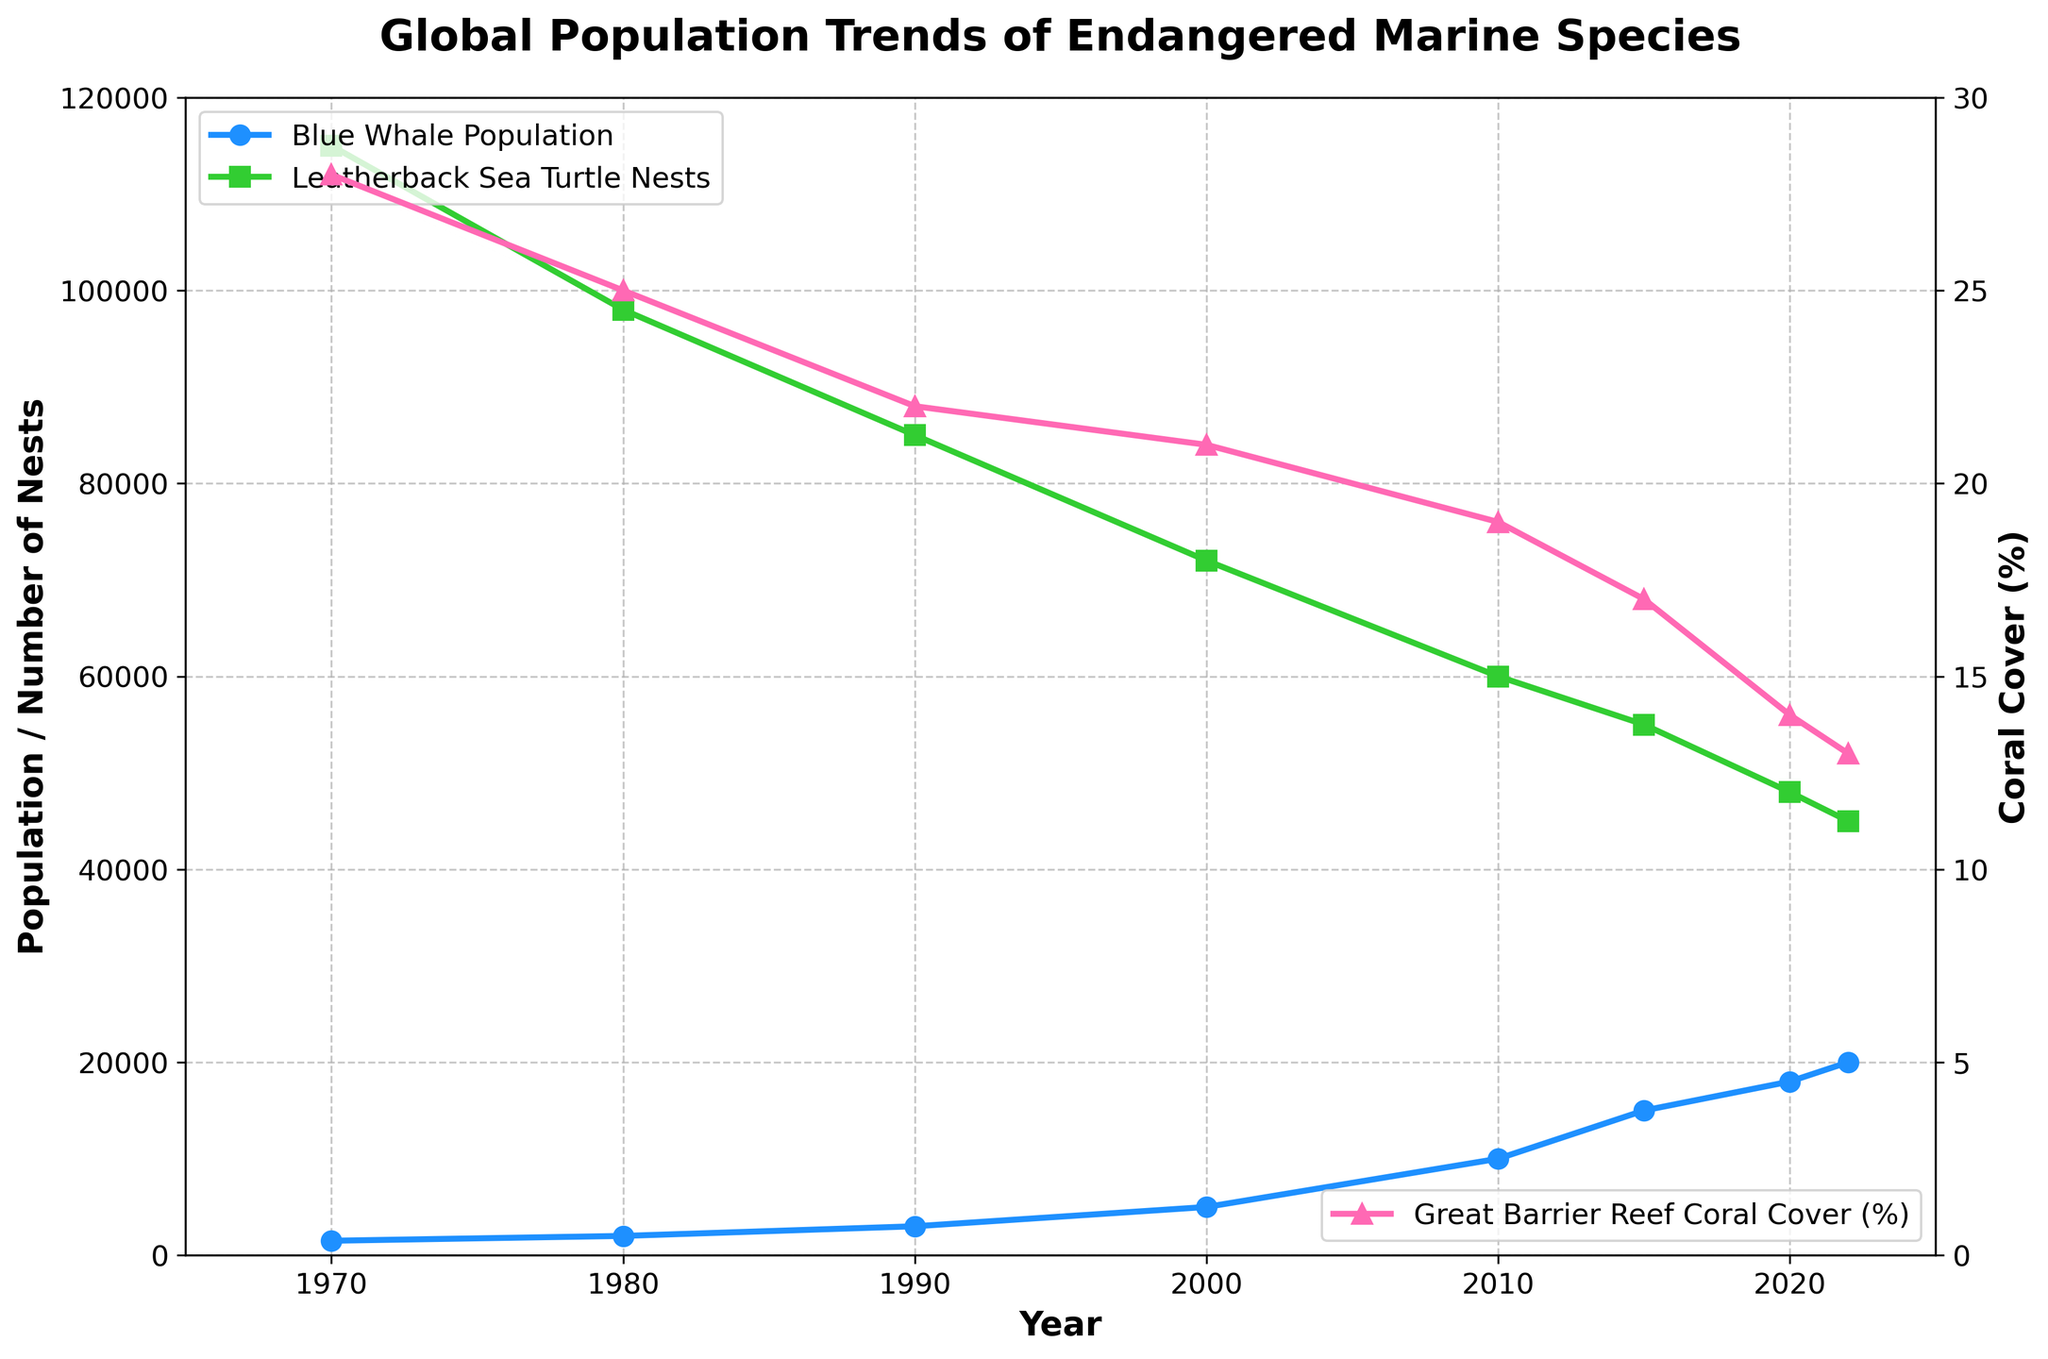What is the trend in the Blue Whale population from 1970 to 2022? The Blue Whale population has increased from 1500 in 1970 to 20000 in 2022. Looking at the line graph, we can see a consistent upward trend over the entire period.
Answer: Blue Whales show an increasing trend What was the population difference of Blue Whales between the years 2000 and 2010? The Blue Whale population in 2000 was 5000, and in 2010 it was 10000. To find the difference, we subtract the 2000 value from the 2010 value: 10000 - 5000 = 5000.
Answer: 5000 How does the Leatherback Sea Turtle nests number in 1990 compare to that in 2020? In 1990, the number of Leatherback Sea Turtle nests was 85000, and in 2020, it was 48000. By comparing these values, we see a significant decrease over this period.
Answer: Decreased What is the average Great Barrier Reef Coral Cover percentage between 1970 and 2015? To find the average, add the percentage values for the years 1970, 1980, 1990, 2000, 2010, and 2015 (28 + 25 + 22 + 21 + 19 + 17) and divide by the number of years (6). So, (28 + 25 + 22 + 21 + 19 + 17) / 6 = 132 / 6 = 22.
Answer: 22 Which species had the steepest decline in the observed period? Looking at the slopes of the lines, the Great Barrier Reef Coral Cover showed the steepest decline from 28% in 1970 to 13% in 2022. Visually, the pink-colored line representing coral cover descends more sharply than the other lines.
Answer: Great Barrier Reef Coral What year did the Blue Whale population reach 15000? From the graph, the Blue Whale population reached 15000 in the year 2015. This is indicated by the intersection of the blue line with the 15000 mark on the Y-axis.
Answer: 2015 If the trends continue, what would be the estimated Coral Cover percentage in 2025? Observing the trend of the pink line, the Great Barrier Reef Coral Cover percentage has been decreasing consistently. Assuming the same rate of decline, it seems the coral cover might drop slightly below 13%, possibly around 11-12%.
Answer: Around 11-12% What is the change in Leatherback Sea Turtle nests from 1980 to 2022? To find the change, subtract the number of nests in 2022 (45000) from the number of nests in 1980 (98000). Thus, 98000 - 45000 = 53000.
Answer: 53000 